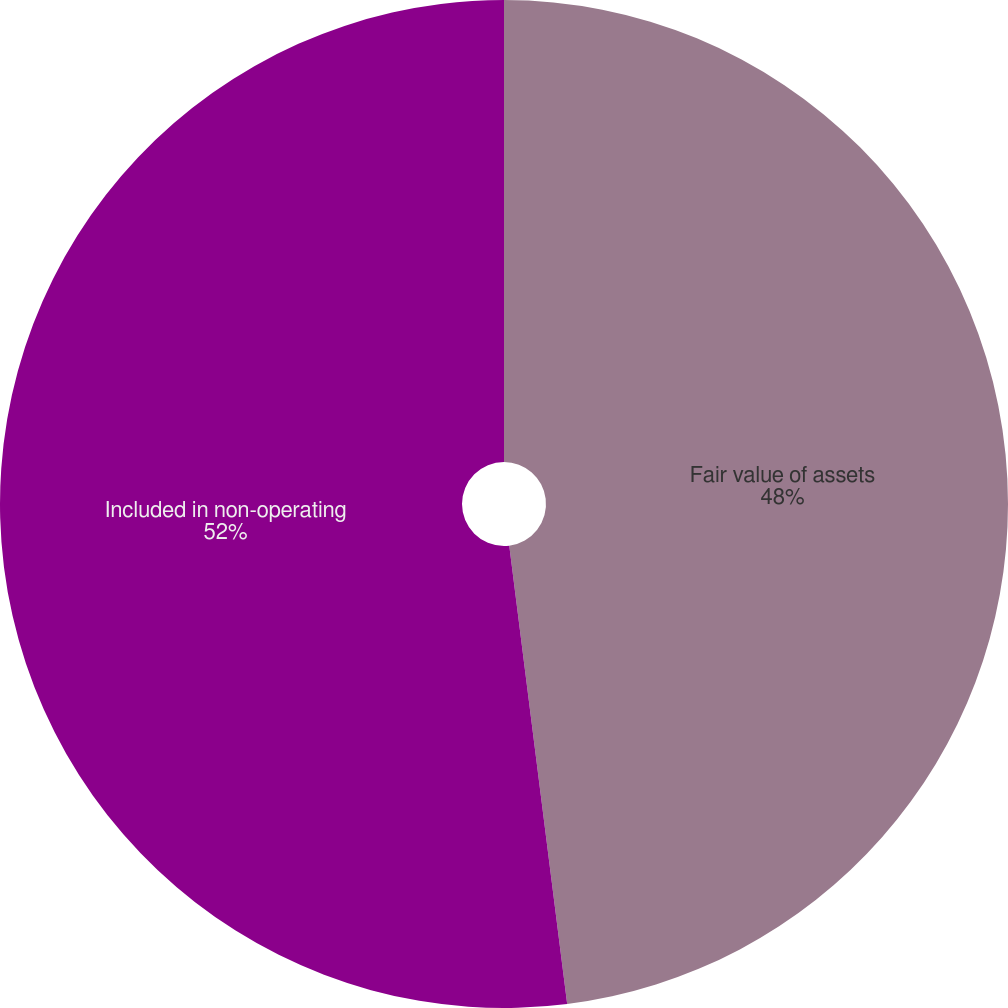Convert chart to OTSL. <chart><loc_0><loc_0><loc_500><loc_500><pie_chart><fcel>Fair value of assets<fcel>Included in non-operating<nl><fcel>48.0%<fcel>52.0%<nl></chart> 